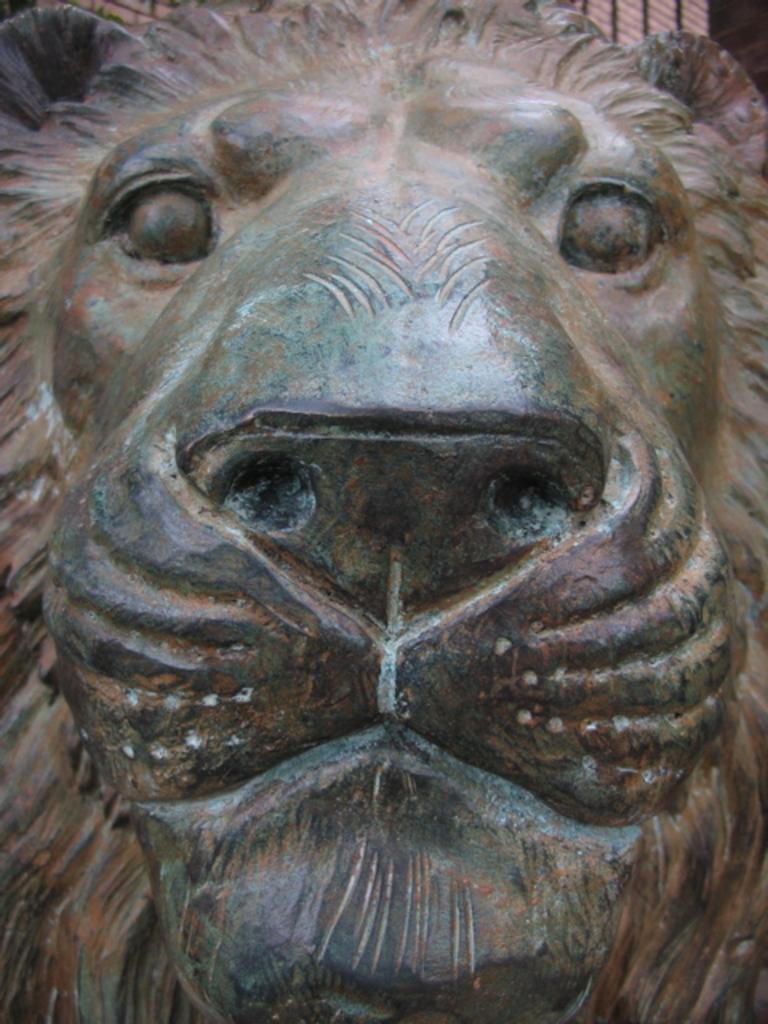How would you summarize this image in a sentence or two? In this image, we can see a statue of a lion. 